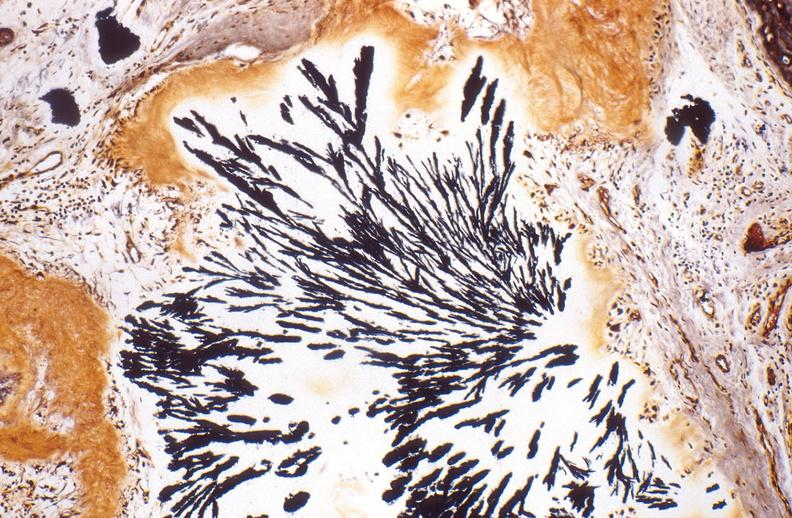s all pelvic organs tumor mass present?
Answer the question using a single word or phrase. No 